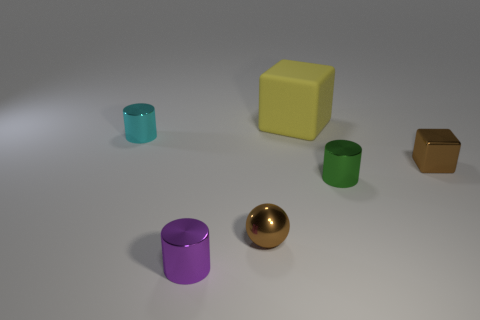Does the metallic block have the same color as the small cylinder that is left of the purple metallic thing?
Give a very brief answer. No. What is the object that is behind the small brown metallic block and to the right of the purple metal cylinder made of?
Provide a succinct answer. Rubber. Are there any metallic cylinders that have the same size as the yellow block?
Offer a very short reply. No. There is a purple cylinder that is the same size as the cyan cylinder; what material is it?
Your answer should be very brief. Metal. How many cyan shiny objects are in front of the brown sphere?
Keep it short and to the point. 0. Do the brown thing that is behind the small brown metal sphere and the big yellow object have the same shape?
Your answer should be very brief. Yes. Is there a brown metallic object of the same shape as the big rubber thing?
Offer a very short reply. Yes. What material is the tiny sphere that is the same color as the small shiny block?
Give a very brief answer. Metal. What is the shape of the tiny object that is in front of the brown metallic thing that is in front of the green metallic cylinder?
Ensure brevity in your answer.  Cylinder. How many large blocks are the same material as the cyan cylinder?
Your answer should be very brief. 0. 